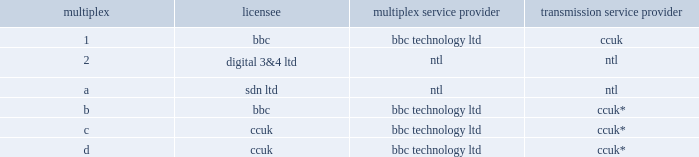Million ( $ 27.6 million at such time ) annually under its transmission contract with itvd .
Itvd represented approximately 12% ( 12 % ) of the 2001 revenues of ccuk and approximately 3% ( 3 % ) of the 2001 consolidated revenues of the company .
In august 2002 , the itc granted the dtt multiplex licenses previously held by itvd to ccuk ( multiplex c and d ) and the bbc ( multiplex b , bringing the bbc 2019s total to two licenses ) .
The dtt multiplex licenses awarded to ccuk have a term of 12 years , and ccuk has the right to renew the licenses for an additional term of 12 years subject to satisfaction of certain performance criteria .
No license fees were paid to the u.k .
Government with respect to the award of the multiplex licenses other than an approximately $ 76000 application fee .
Following the award of such licenses , the current u.k .
Dtt multiplex licensing structure is as follows: .
* broadcasting service provided in connection with freeview brand .
On october 30 , 2002 , the bbc , ccuk and bskyb launched a multi-channel digital tv and radio broadcasting service under the brand 201cfreeview . 201d freeview is a free-to-air broadcast service and is received by viewers via a set- top box or other device .
At the end of 2003 , there were approximately three million such devices in service , in contrast to the approximately 1.2 million set-top boxes in service with respect to itvd service 20 months prior .
Our revenue derived from broadcast transmission services ( including distribution and multiplexing ) relating to freeview is contractually based and therefore is not directly dependent on the number of freeview viewers .
In connection with the launch of freeview , in august 2002 ccuk entered into an agreement with the bbc to provide broadcast transmission along with distribution service for the second multiplex license ( multiplex b ) awarded to the bbc .
Also in august 2002 , ccuk entered into an agreement with bskyb to provide broadcast transmission along with distribution and multiplexing service in relation to 75% ( 75 % ) of the capacity of one of the ccuk multiplexes ( multiplex c ) .
Both of these agreements are for an initial period of six years with options for the bbc and bskyb to extend for an additional six-year term .
In addition , ccuk has entered into agreements to provide similar service to a number of tv , radio and interactive service content providers ( including uktv , flextech , viacom , emap , mietv , oneword , guardian media group and bbc world service ) through the two multiplexes awarded to ccuk .
Freeview related agreements with the television content providers are also for six-year terms , with renewal options , while agreements with radio and interactive service providers are generally for shorter terms .
Through such agreements , ccuk is currently transmitting content for such customers with respect to approximately 90% ( 90 % ) of its licensed capacity and is negotiating with content providers with respect to the remaining capacity .
Ccuk has contracted annual revenues of approximately a327.2 million ( $ 48.5 million ) for the provision of transmission , distribution and multiplexing services related to its multiplex licenses , which replaces the approximately a319.4 million annual revenues previously earned from the itvd contract and is in addition to the revenues generated from the 1998 bbc digital transmission contract .
See 201cbusiness 2014the company 2014u.k .
Operations 2014significant contracts 20141998 bbc dtt transmission contract 201d , 201c 20142002 bbc dtt transmission contract 201d and 201c 2014bskyb and other freeview content dtt transmission contracts . 201d as a result of its previous contract with itvd , ccuk had already invested substantially all of the capital required to provide the freeview related broadcast transmission service described above .
In addition , ccuk had previously been incurring , again by virtue of its previous contract with itvd , a large proportion of the operating costs required to provide these services ( including payments to bt for distribution circuits and payments to ntl for site rental ) .
Since ccuk is providing a more complete end-to-end service to content providers than was provided to itvd , ccuk is incurring certain additional annual operating costs of approximately a34.6 million ( $ 8.2 million ) .
What is the operating expense ratio for ccuk ( in millions ) ? 
Rationale: the operating expense ratio is the operating expensive divided by the revenue . line 19 has the revenue for ccuk and line 23 has the operating costs for ccuk .
Computations: (8.2 / 48.5)
Answer: 0.16907. 